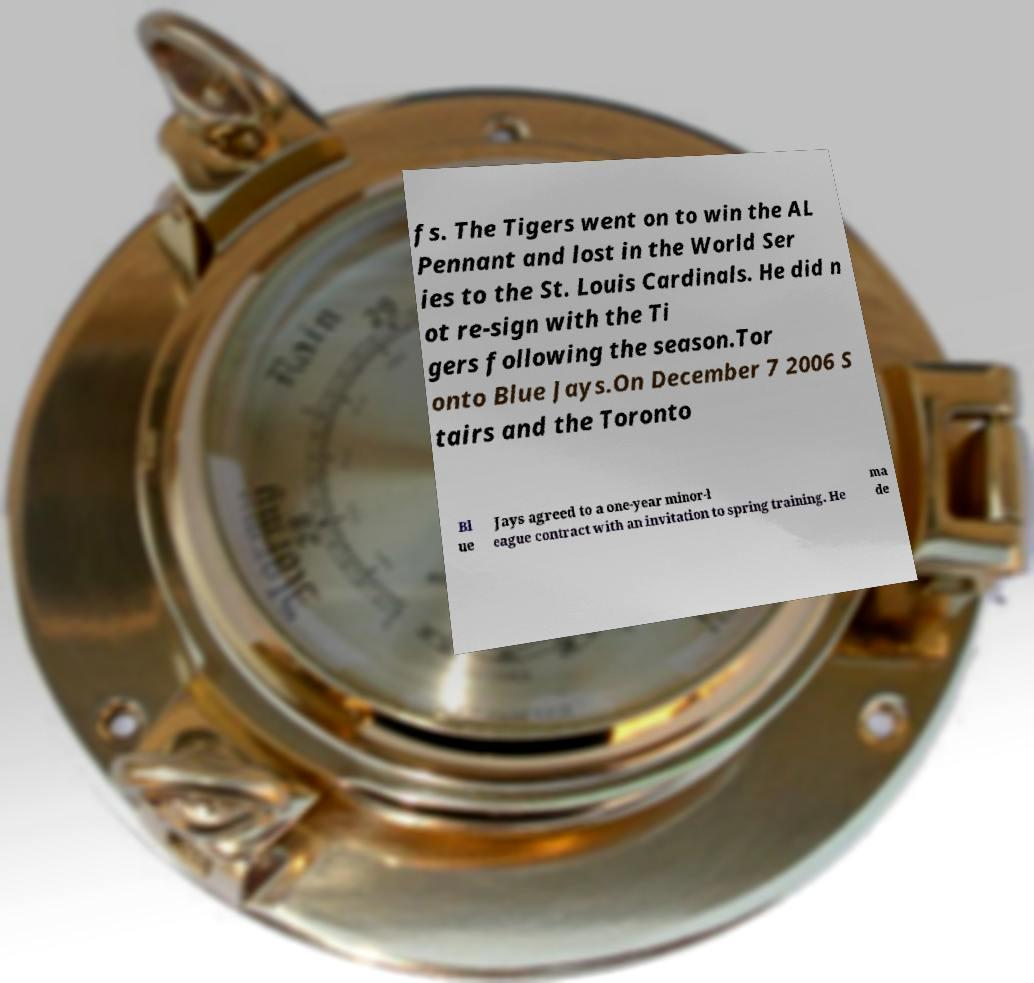Please read and relay the text visible in this image. What does it say? fs. The Tigers went on to win the AL Pennant and lost in the World Ser ies to the St. Louis Cardinals. He did n ot re-sign with the Ti gers following the season.Tor onto Blue Jays.On December 7 2006 S tairs and the Toronto Bl ue Jays agreed to a one-year minor-l eague contract with an invitation to spring training. He ma de 